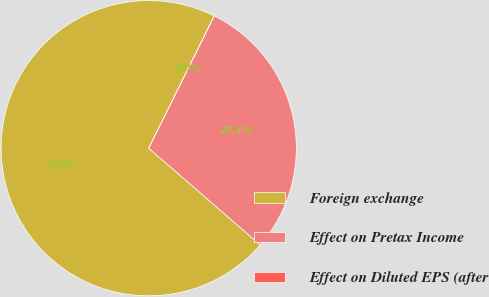Convert chart. <chart><loc_0><loc_0><loc_500><loc_500><pie_chart><fcel>Foreign exchange<fcel>Effect on Pretax Income<fcel>Effect on Diluted EPS (after<nl><fcel>70.94%<fcel>29.05%<fcel>0.0%<nl></chart> 